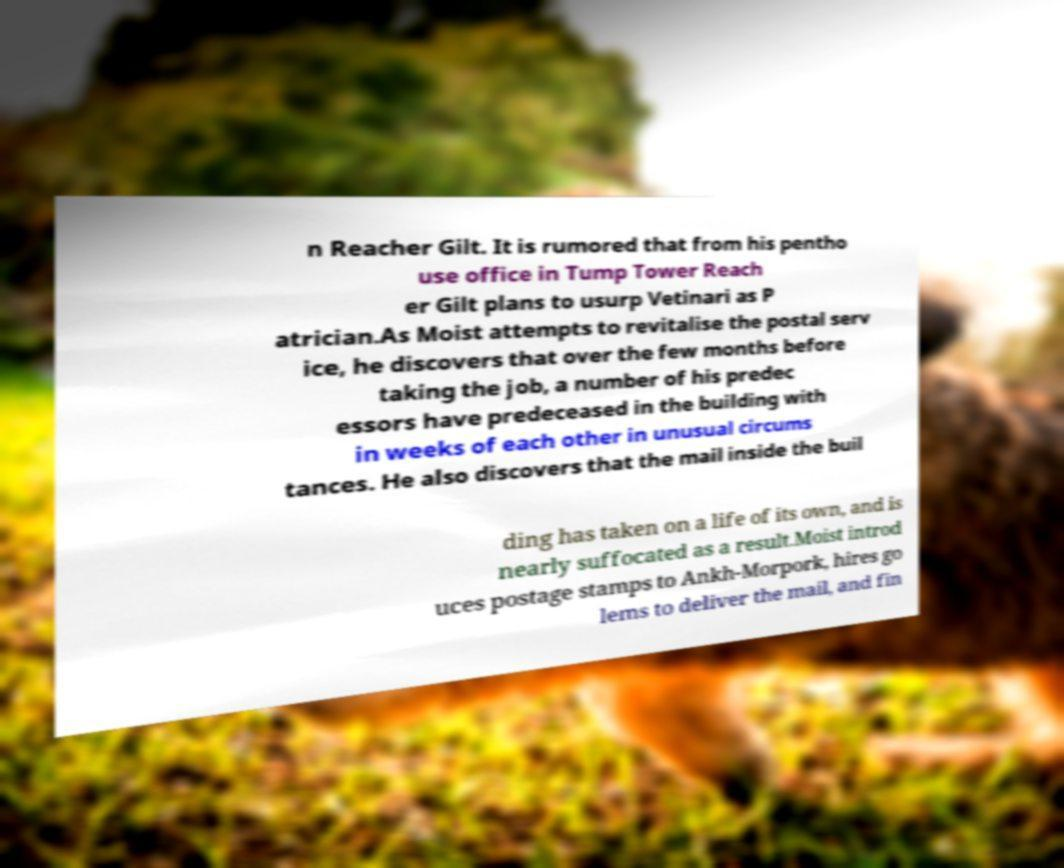Please identify and transcribe the text found in this image. n Reacher Gilt. It is rumored that from his pentho use office in Tump Tower Reach er Gilt plans to usurp Vetinari as P atrician.As Moist attempts to revitalise the postal serv ice, he discovers that over the few months before taking the job, a number of his predec essors have predeceased in the building with in weeks of each other in unusual circums tances. He also discovers that the mail inside the buil ding has taken on a life of its own, and is nearly suffocated as a result.Moist introd uces postage stamps to Ankh-Morpork, hires go lems to deliver the mail, and fin 